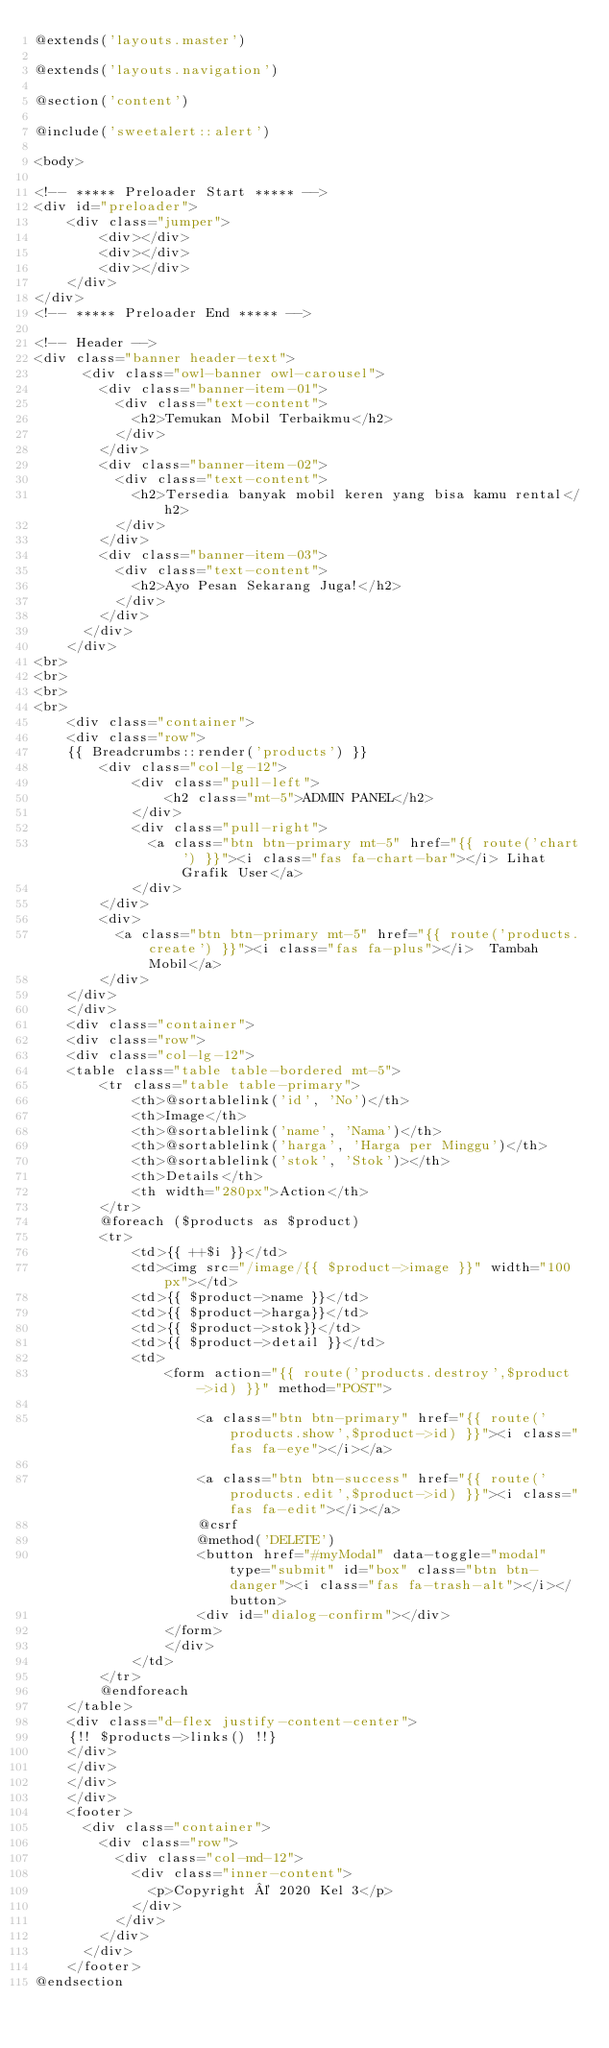<code> <loc_0><loc_0><loc_500><loc_500><_PHP_>@extends('layouts.master')

@extends('layouts.navigation')

@section('content')

@include('sweetalert::alert')

<body>

<!-- ***** Preloader Start ***** -->
<div id="preloader">
    <div class="jumper">
        <div></div>
        <div></div>
        <div></div>
    </div>
</div>  
<!-- ***** Preloader End ***** -->

<!-- Header -->
<div class="banner header-text">
      <div class="owl-banner owl-carousel">
        <div class="banner-item-01">
          <div class="text-content">
            <h2>Temukan Mobil Terbaikmu</h2>
          </div>
        </div>
        <div class="banner-item-02">
          <div class="text-content">
            <h2>Tersedia banyak mobil keren yang bisa kamu rental</h2>
          </div>
        </div>
        <div class="banner-item-03">
          <div class="text-content">
            <h2>Ayo Pesan Sekarang Juga!</h2>
          </div>
        </div>
      </div>
    </div>
<br>
<br>
<br>
<br>
    <div class="container">
    <div class="row">
    {{ Breadcrumbs::render('products') }}
        <div class="col-lg-12">
            <div class="pull-left">
                <h2 class="mt-5">ADMIN PANEL</h2>
            </div>
            <div class="pull-right">
              <a class="btn btn-primary mt-5" href="{{ route('chart') }}"><i class="fas fa-chart-bar"></i> Lihat Grafik User</a>
            </div>
        </div>
        <div>
          <a class="btn btn-primary mt-5" href="{{ route('products.create') }}"><i class="fas fa-plus"></i>  Tambah Mobil</a>
        </div>
    </div>
    </div>
    <div class="container">
    <div class="row">
    <div class="col-lg-12">
    <table class="table table-bordered mt-5">
        <tr class="table table-primary">
            <th>@sortablelink('id', 'No')</th>
            <th>Image</th>
            <th>@sortablelink('name', 'Nama')</th>
            <th>@sortablelink('harga', 'Harga per Minggu')</th>
            <th>@sortablelink('stok', 'Stok')></th>
            <th>Details</th>
            <th width="280px">Action</th>
        </tr>
        @foreach ($products as $product)
        <tr>
            <td>{{ ++$i }}</td>
            <td><img src="/image/{{ $product->image }}" width="100px"></td>
            <td>{{ $product->name }}</td>
            <td>{{ $product->harga}}</td>
            <td>{{ $product->stok}}</td>
            <td>{{ $product->detail }}</td>
            <td>
                <form action="{{ route('products.destroy',$product->id) }}" method="POST">
     
                    <a class="btn btn-primary" href="{{ route('products.show',$product->id) }}"><i class="fas fa-eye"></i></a>
      
                    <a class="btn btn-success" href="{{ route('products.edit',$product->id) }}"><i class="fas fa-edit"></i></a>
                    @csrf
                    @method('DELETE')
                    <button href="#myModal" data-toggle="modal" type="submit" id="box" class="btn btn-danger"><i class="fas fa-trash-alt"></i></button>
                    <div id="dialog-confirm"></div>
                </form>
                </div>
            </td>
        </tr>
        @endforeach
    </table>  
    <div class="d-flex justify-content-center">
    {!! $products->links() !!}
    </div>
    </div>  
    </div>
    </div>
    <footer>
      <div class="container">
        <div class="row">
          <div class="col-md-12">
            <div class="inner-content">
              <p>Copyright © 2020 Kel 3</p>
            </div>
          </div>
        </div>
      </div>
    </footer>
@endsection</code> 